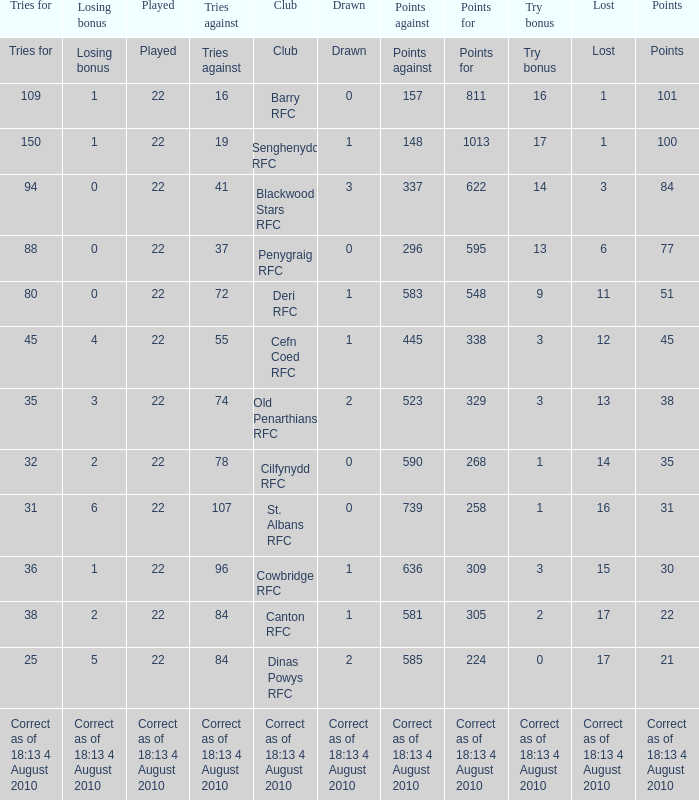What is the played number when tries against is 84, and drawn is 2? 22.0. 